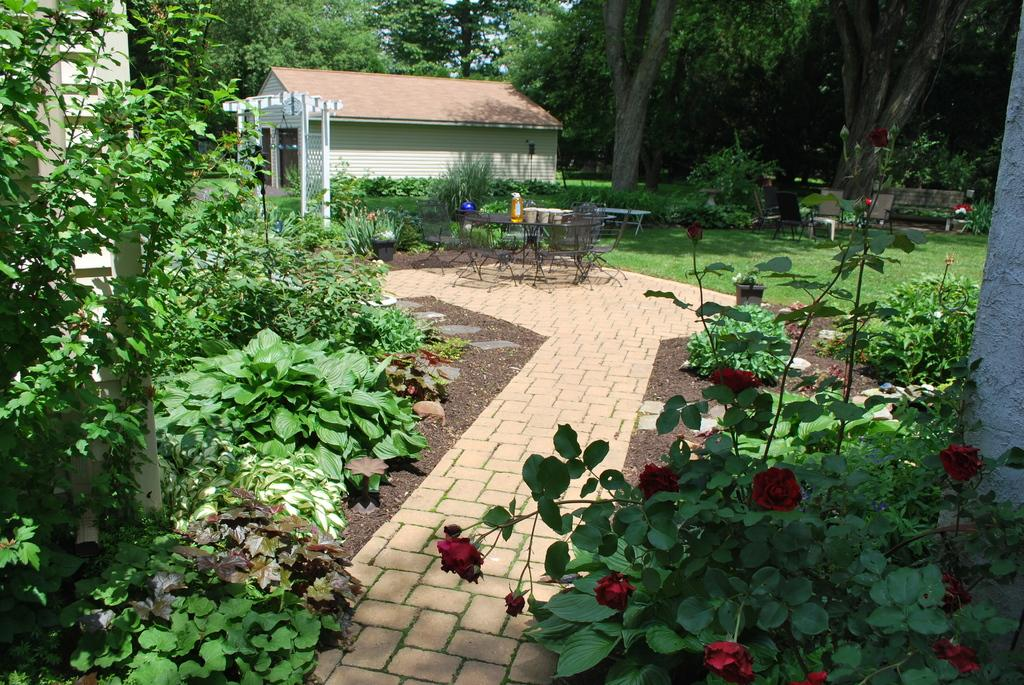What type of flooring is visible in the image? There are tiles placed on the ground in the image. What can be seen on either side of the tiles? There are plants on either side of the tiles. What is visible in the background of the image? There is a house and trees in the background. What type of fire can be seen burning in the image? There is no fire present in the image. What wish is granted to the person in the image? There is no person or wish granted in the image. 